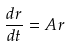Convert formula to latex. <formula><loc_0><loc_0><loc_500><loc_500>\frac { d r } { d t } = A r</formula> 